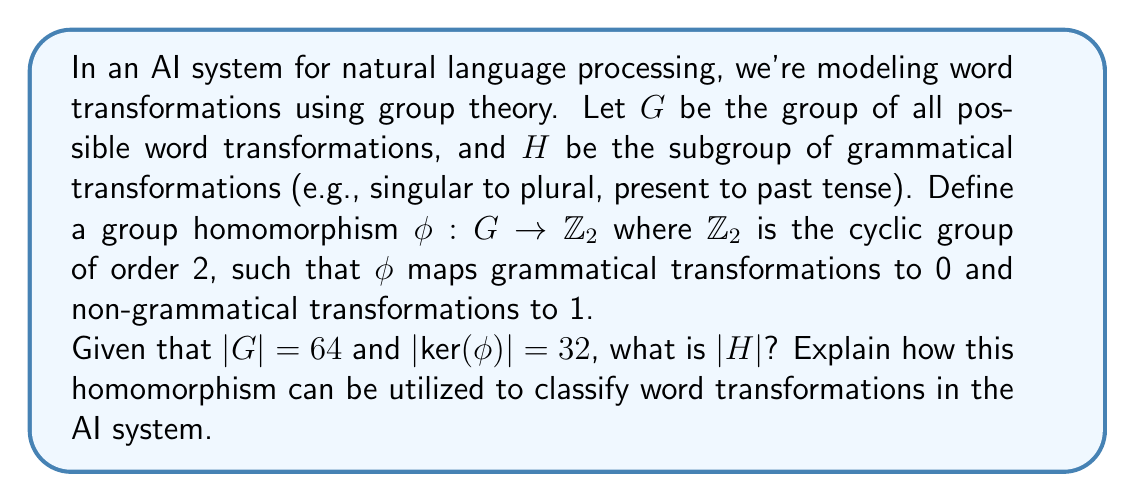Teach me how to tackle this problem. To solve this problem, we'll use the properties of group homomorphisms and the First Isomorphism Theorem. Let's break it down step-by-step:

1) First, recall the First Isomorphism Theorem: For a group homomorphism $\phi: G \rightarrow H$, we have $G/\text{ker}(\phi) \cong \text{im}(\phi)$.

2) In this case, $\phi: G \rightarrow \mathbb{Z}_2$. We know that $|\mathbb{Z}_2| = 2$, so $|\text{im}(\phi)| \leq 2$.

3) Since $\phi$ maps to both 0 and 1 (grammatical and non-grammatical transformations), $|\text{im}(\phi)| = 2$.

4) We're given that $|G| = 64$ and $|\text{ker}(\phi)| = 32$.

5) Using the First Isomorphism Theorem:

   $|G/\text{ker}(\phi)| = |G| / |\text{ker}(\phi)| = 64 / 32 = 2 = |\text{im}(\phi)|$

6) Now, $\text{ker}(\phi)$ contains all elements of $G$ that map to the identity element of $\mathbb{Z}_2$, which is 0. By the definition of $\phi$, these are exactly the grammatical transformations.

7) Therefore, $H = \text{ker}(\phi)$, and $|H| = |\text{ker}(\phi)| = 32$.

Utilization in AI system:
This homomorphism provides a way to classify word transformations as either grammatical (0) or non-grammatical (1). The AI system can use this to:

a) Quickly determine if a transformation is grammatical without needing to check against a full list of grammatical rules.
b) Group similar transformations together, potentially improving efficiency in natural language processing tasks.
c) Identify patterns in non-grammatical transformations, which could be useful for error correction or understanding common mistakes in language learning.
d) Reduce the dimensionality of the transformation space from 64 possible transformations to a binary classification, which can be computationally efficient for large-scale language processing tasks.
Answer: $|H| = 32$ 